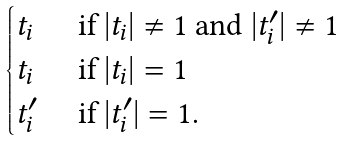<formula> <loc_0><loc_0><loc_500><loc_500>\begin{cases} t _ { i } & \text { if } | t _ { i } | \neq 1 \text { and } | t ^ { \prime } _ { i } | \neq 1 \\ t _ { i } & \text { if } | t _ { i } | = 1 \\ t ^ { \prime } _ { i } & \text { if } | t ^ { \prime } _ { i } | = 1 . \end{cases}</formula> 